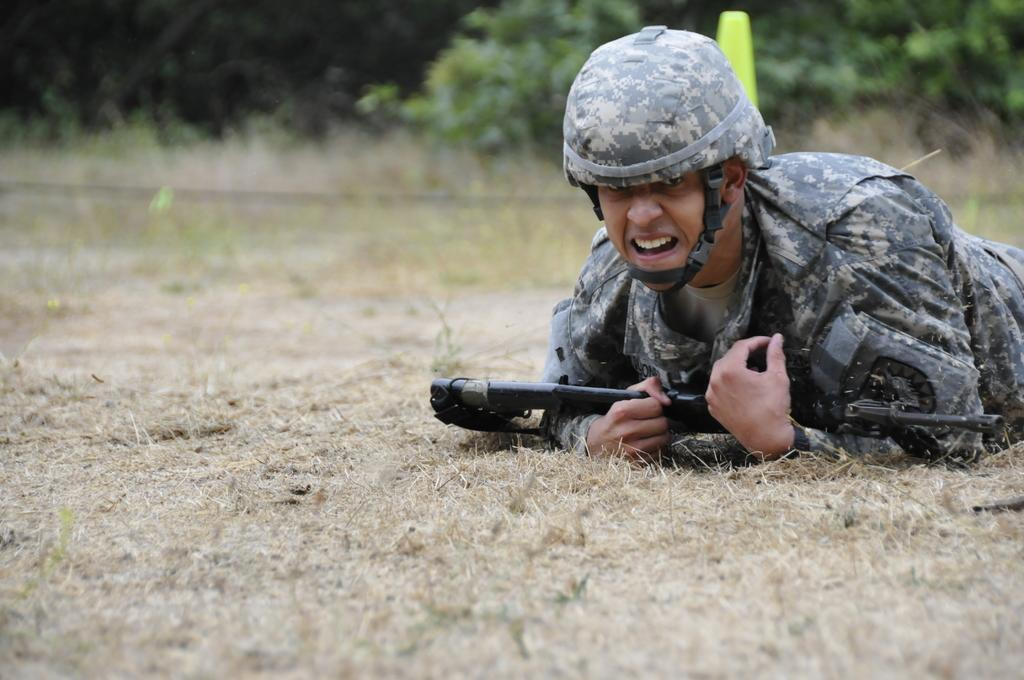Who is present in the image? There is a man in the image. What is the man doing in the image? The man is laying on the ground. What is the man wearing on his head? The man is wearing a helmet. What object is the man holding in his hand? The man is holding a gun in his hand. What can be seen in the background of the image? There are trees in the background of the image. What type of riddle can be solved by the man in the image? There is no riddle present in the image, nor is the man solving one. How does the man amuse himself in the image? The image does not provide information about the man's amusement or entertainment. 